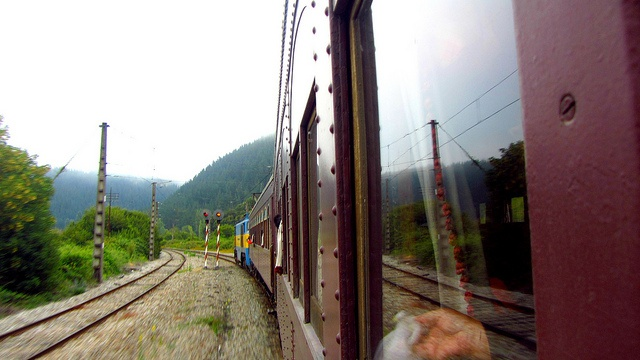Describe the objects in this image and their specific colors. I can see train in white, maroon, black, and gray tones, people in white, gray, brown, black, and maroon tones, traffic light in white, gray, maroon, red, and gold tones, and traffic light in white, maroon, brown, and red tones in this image. 